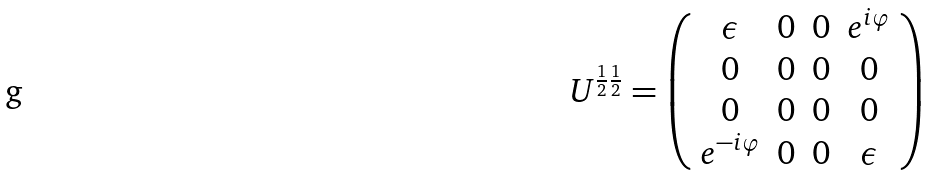<formula> <loc_0><loc_0><loc_500><loc_500>U ^ { \frac { 1 } { 2 } \frac { 1 } { 2 } } = \left ( \begin{array} { c c c c } \epsilon & 0 & 0 & e ^ { i \varphi } \\ 0 & 0 & 0 & 0 \\ 0 & 0 & 0 & 0 \\ e ^ { - i \varphi } & 0 & 0 & \epsilon \end{array} \right )</formula> 